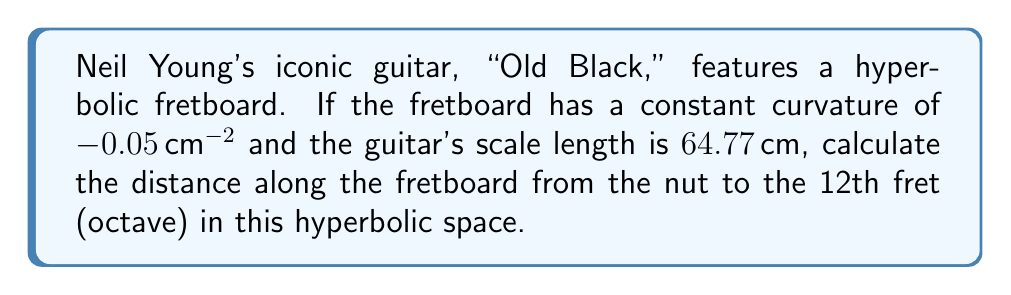Could you help me with this problem? To solve this problem, we'll use the properties of hyperbolic geometry and the given information:

1) In Euclidean geometry, the 12th fret would be located at half the scale length. However, in hyperbolic space, we need to use hyperbolic functions.

2) The distance along a curve in hyperbolic space with constant negative curvature $K$ is given by:

   $$s = \frac{1}{\sqrt{-K}} \cdot \text{arcsinh}\left(\sqrt{-K} \cdot x\right)$$

   where $s$ is the distance along the curve and $x$ is the Euclidean distance.

3) We're given:
   - Curvature $K = -0.05$ cm^(-2)
   - Scale length = 64.77 cm
   - We want to find the distance to the 12th fret, which in Euclidean space would be at $x = 64.77/2 = 32.385$ cm

4) Substituting these values into our equation:

   $$s = \frac{1}{\sqrt{0.05}} \cdot \text{arcsinh}\left(\sqrt{0.05} \cdot 32.385\right)$$

5) Simplify:
   $$s = \frac{1}{0.2236} \cdot \text{arcsinh}(7.2413)$$

6) Calculate:
   $$s = 4.4721 \cdot 2.6453 = 11.8300$$ cm

Therefore, the distance along the hyperbolic fretboard from the nut to the 12th fret is approximately 11.83 cm.
Answer: 11.83 cm 